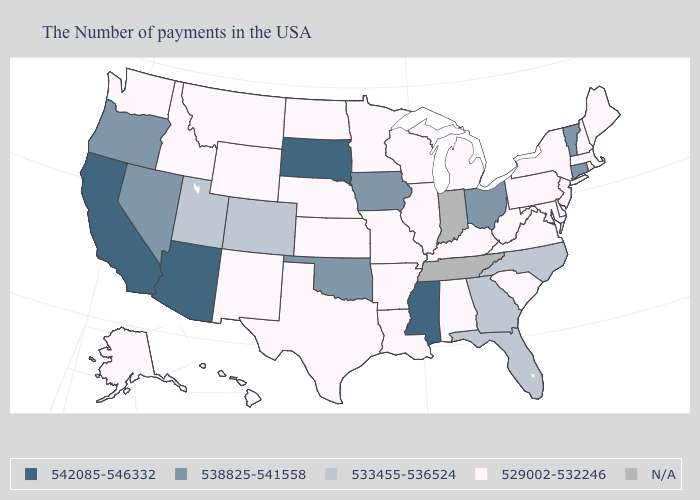Name the states that have a value in the range N/A?
Keep it brief. Indiana, Tennessee. What is the value of Nevada?
Short answer required. 538825-541558. What is the value of Pennsylvania?
Concise answer only. 529002-532246. Which states have the highest value in the USA?
Quick response, please. Mississippi, South Dakota, Arizona, California. What is the lowest value in the USA?
Answer briefly. 529002-532246. Name the states that have a value in the range 542085-546332?
Give a very brief answer. Mississippi, South Dakota, Arizona, California. Among the states that border Indiana , which have the highest value?
Keep it brief. Ohio. Name the states that have a value in the range N/A?
Keep it brief. Indiana, Tennessee. What is the highest value in the West ?
Answer briefly. 542085-546332. What is the value of Massachusetts?
Write a very short answer. 529002-532246. What is the value of Alaska?
Keep it brief. 529002-532246. Is the legend a continuous bar?
Write a very short answer. No. Among the states that border Iowa , which have the highest value?
Write a very short answer. South Dakota. Among the states that border Indiana , does Michigan have the lowest value?
Concise answer only. Yes. 